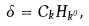Convert formula to latex. <formula><loc_0><loc_0><loc_500><loc_500>\Lambda = C _ { k } H _ { k ^ { 0 } } ,</formula> 